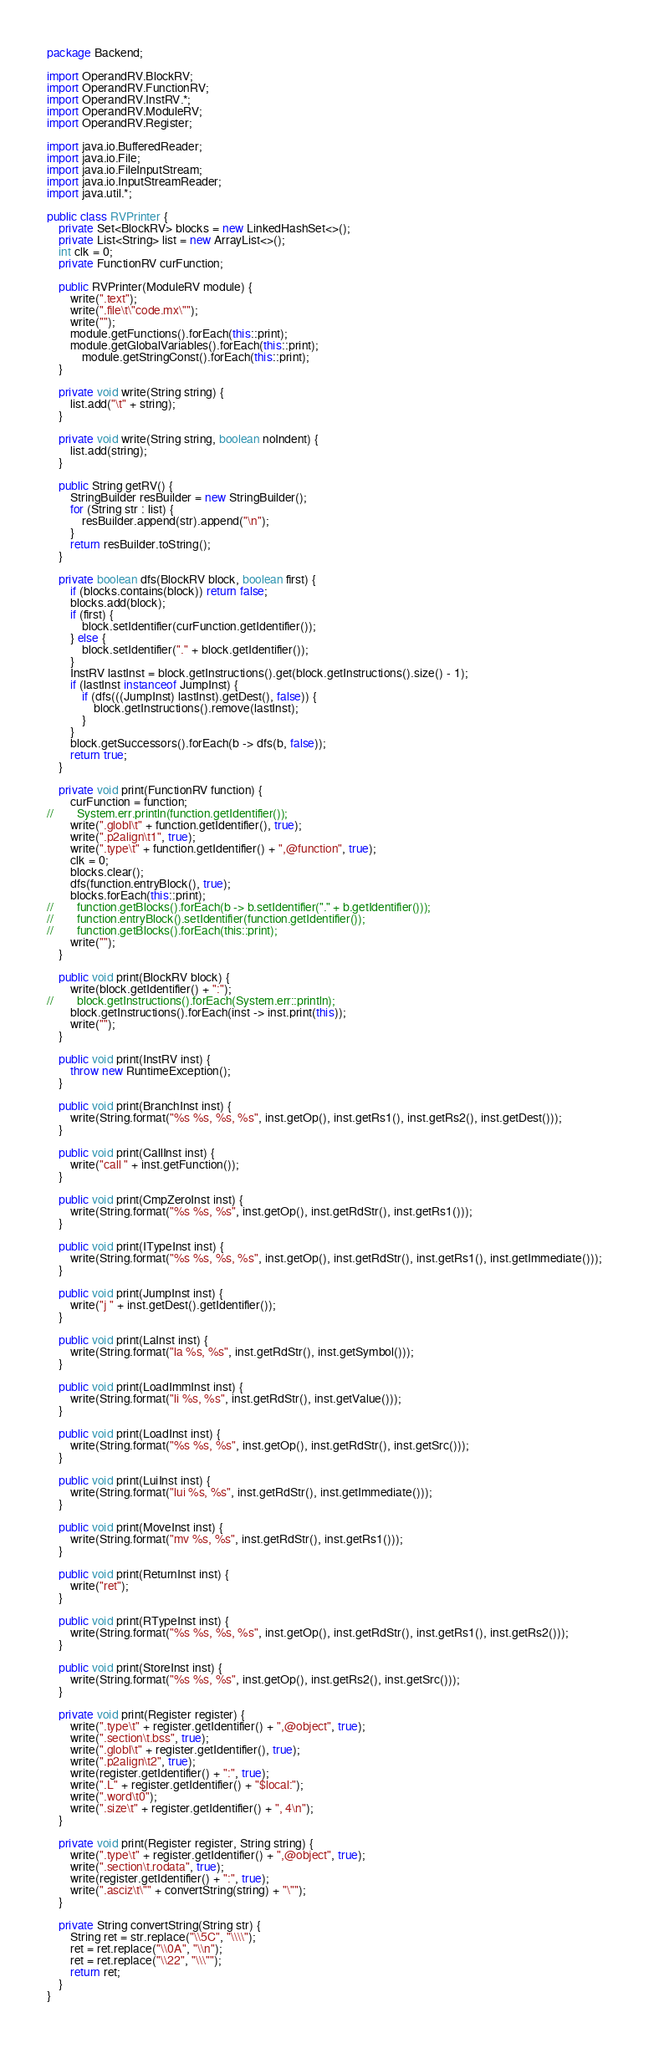<code> <loc_0><loc_0><loc_500><loc_500><_Java_>package Backend;

import OperandRV.BlockRV;
import OperandRV.FunctionRV;
import OperandRV.InstRV.*;
import OperandRV.ModuleRV;
import OperandRV.Register;

import java.io.BufferedReader;
import java.io.File;
import java.io.FileInputStream;
import java.io.InputStreamReader;
import java.util.*;

public class RVPrinter {
    private Set<BlockRV> blocks = new LinkedHashSet<>();
    private List<String> list = new ArrayList<>();
    int clk = 0;
    private FunctionRV curFunction;

    public RVPrinter(ModuleRV module) {
        write(".text");
        write(".file\t\"code.mx\"");
        write("");
        module.getFunctions().forEach(this::print);
        module.getGlobalVariables().forEach(this::print);
            module.getStringConst().forEach(this::print);
    }

    private void write(String string) {
        list.add("\t" + string);
    }

    private void write(String string, boolean noIndent) {
        list.add(string);
    }

    public String getRV() {
        StringBuilder resBuilder = new StringBuilder();
        for (String str : list) {
            resBuilder.append(str).append("\n");
        }
        return resBuilder.toString();
    }

    private boolean dfs(BlockRV block, boolean first) {
        if (blocks.contains(block)) return false;
        blocks.add(block);
        if (first) {
            block.setIdentifier(curFunction.getIdentifier());
        } else {
            block.setIdentifier("." + block.getIdentifier());
        }
        InstRV lastInst = block.getInstructions().get(block.getInstructions().size() - 1);
        if (lastInst instanceof JumpInst) {
            if (dfs(((JumpInst) lastInst).getDest(), false)) {
                block.getInstructions().remove(lastInst);
            }
        }
        block.getSuccessors().forEach(b -> dfs(b, false));
        return true;
    }

    private void print(FunctionRV function) {
        curFunction = function;
//        System.err.println(function.getIdentifier());
        write(".globl\t" + function.getIdentifier(), true);
        write(".p2align\t1", true);
        write(".type\t" + function.getIdentifier() + ",@function", true);
        clk = 0;
        blocks.clear();
        dfs(function.entryBlock(), true);
        blocks.forEach(this::print);
//        function.getBlocks().forEach(b -> b.setIdentifier("." + b.getIdentifier()));
//        function.entryBlock().setIdentifier(function.getIdentifier());
//        function.getBlocks().forEach(this::print);
        write("");
    }

    public void print(BlockRV block) {
        write(block.getIdentifier() + ":");
//        block.getInstructions().forEach(System.err::println);
        block.getInstructions().forEach(inst -> inst.print(this));
        write("");
    }

    public void print(InstRV inst) {
        throw new RuntimeException();
    }

    public void print(BranchInst inst) {
        write(String.format("%s %s, %s, %s", inst.getOp(), inst.getRs1(), inst.getRs2(), inst.getDest()));
    }

    public void print(CallInst inst) {
        write("call " + inst.getFunction());
    }

    public void print(CmpZeroInst inst) {
        write(String.format("%s %s, %s", inst.getOp(), inst.getRdStr(), inst.getRs1()));
    }

    public void print(ITypeInst inst) {
        write(String.format("%s %s, %s, %s", inst.getOp(), inst.getRdStr(), inst.getRs1(), inst.getImmediate()));
    }

    public void print(JumpInst inst) {
        write("j " + inst.getDest().getIdentifier());
    }

    public void print(LaInst inst) {
        write(String.format("la %s, %s", inst.getRdStr(), inst.getSymbol()));
    }

    public void print(LoadImmInst inst) {
        write(String.format("li %s, %s", inst.getRdStr(), inst.getValue()));
    }

    public void print(LoadInst inst) {
        write(String.format("%s %s, %s", inst.getOp(), inst.getRdStr(), inst.getSrc()));
    }

    public void print(LuiInst inst) {
        write(String.format("lui %s, %s", inst.getRdStr(), inst.getImmediate()));
    }

    public void print(MoveInst inst) {
        write(String.format("mv %s, %s", inst.getRdStr(), inst.getRs1()));
    }

    public void print(ReturnInst inst) {
        write("ret");
    }

    public void print(RTypeInst inst) {
        write(String.format("%s %s, %s, %s", inst.getOp(), inst.getRdStr(), inst.getRs1(), inst.getRs2()));
    }

    public void print(StoreInst inst) {
        write(String.format("%s %s, %s", inst.getOp(), inst.getRs2(), inst.getSrc()));
    }

    private void print(Register register) {
        write(".type\t" + register.getIdentifier() + ",@object", true);
        write(".section\t.bss", true);
        write(".globl\t" + register.getIdentifier(), true);
        write(".p2align\t2", true);
        write(register.getIdentifier() + ":", true);
        write(".L" + register.getIdentifier() + "$local:");
        write(".word\t0");
        write(".size\t" + register.getIdentifier() + ", 4\n");
    }

    private void print(Register register, String string) {
        write(".type\t" + register.getIdentifier() + ",@object", true);
        write(".section\t.rodata", true);
        write(register.getIdentifier() + ":", true);
        write(".asciz\t\"" + convertString(string) + "\"");
    }

    private String convertString(String str) {
        String ret = str.replace("\\5C", "\\\\");
        ret = ret.replace("\\0A", "\\n");
        ret = ret.replace("\\22", "\\\"");
        return ret;
    }
}
</code> 